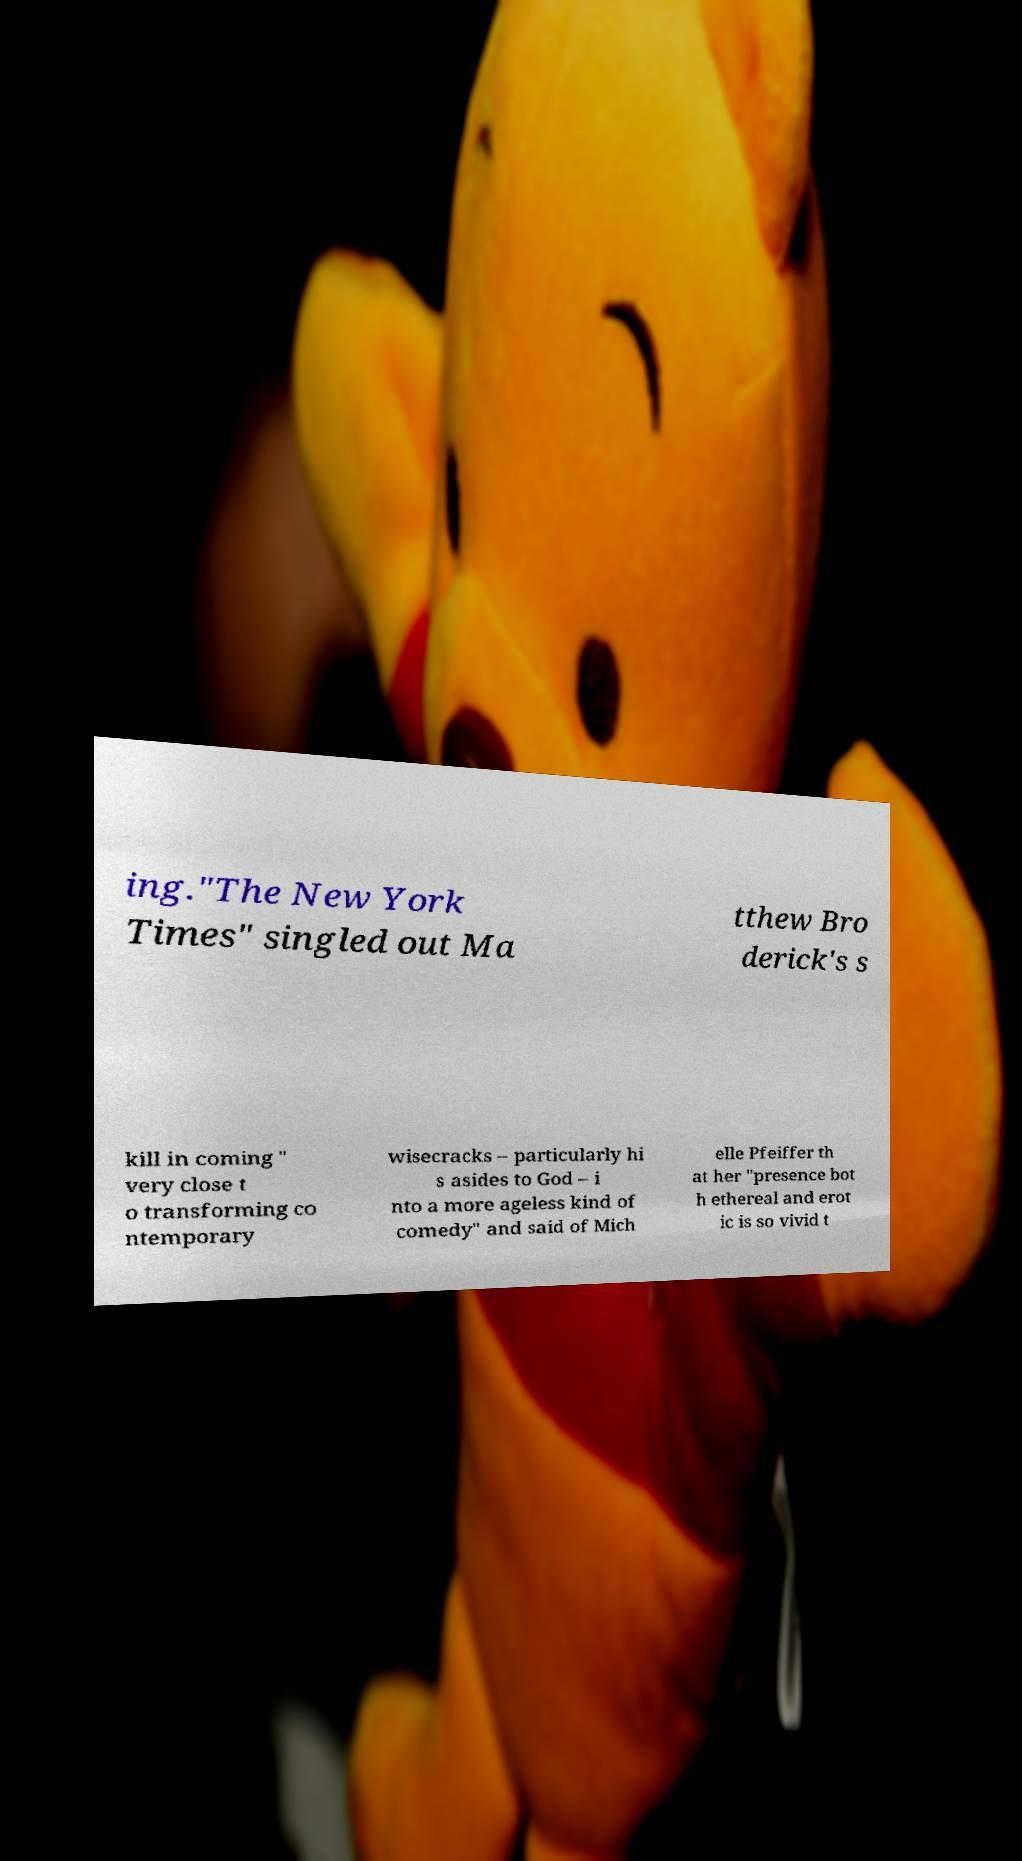There's text embedded in this image that I need extracted. Can you transcribe it verbatim? ing."The New York Times" singled out Ma tthew Bro derick's s kill in coming " very close t o transforming co ntemporary wisecracks – particularly hi s asides to God – i nto a more ageless kind of comedy" and said of Mich elle Pfeiffer th at her "presence bot h ethereal and erot ic is so vivid t 